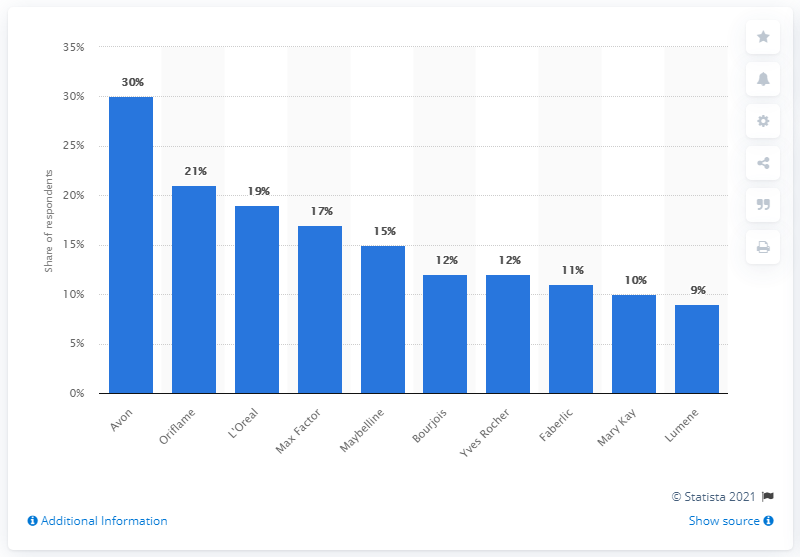Point out several critical features in this image. The most popular cosmetic make-up brand in Russia in 2013 was Avon. 